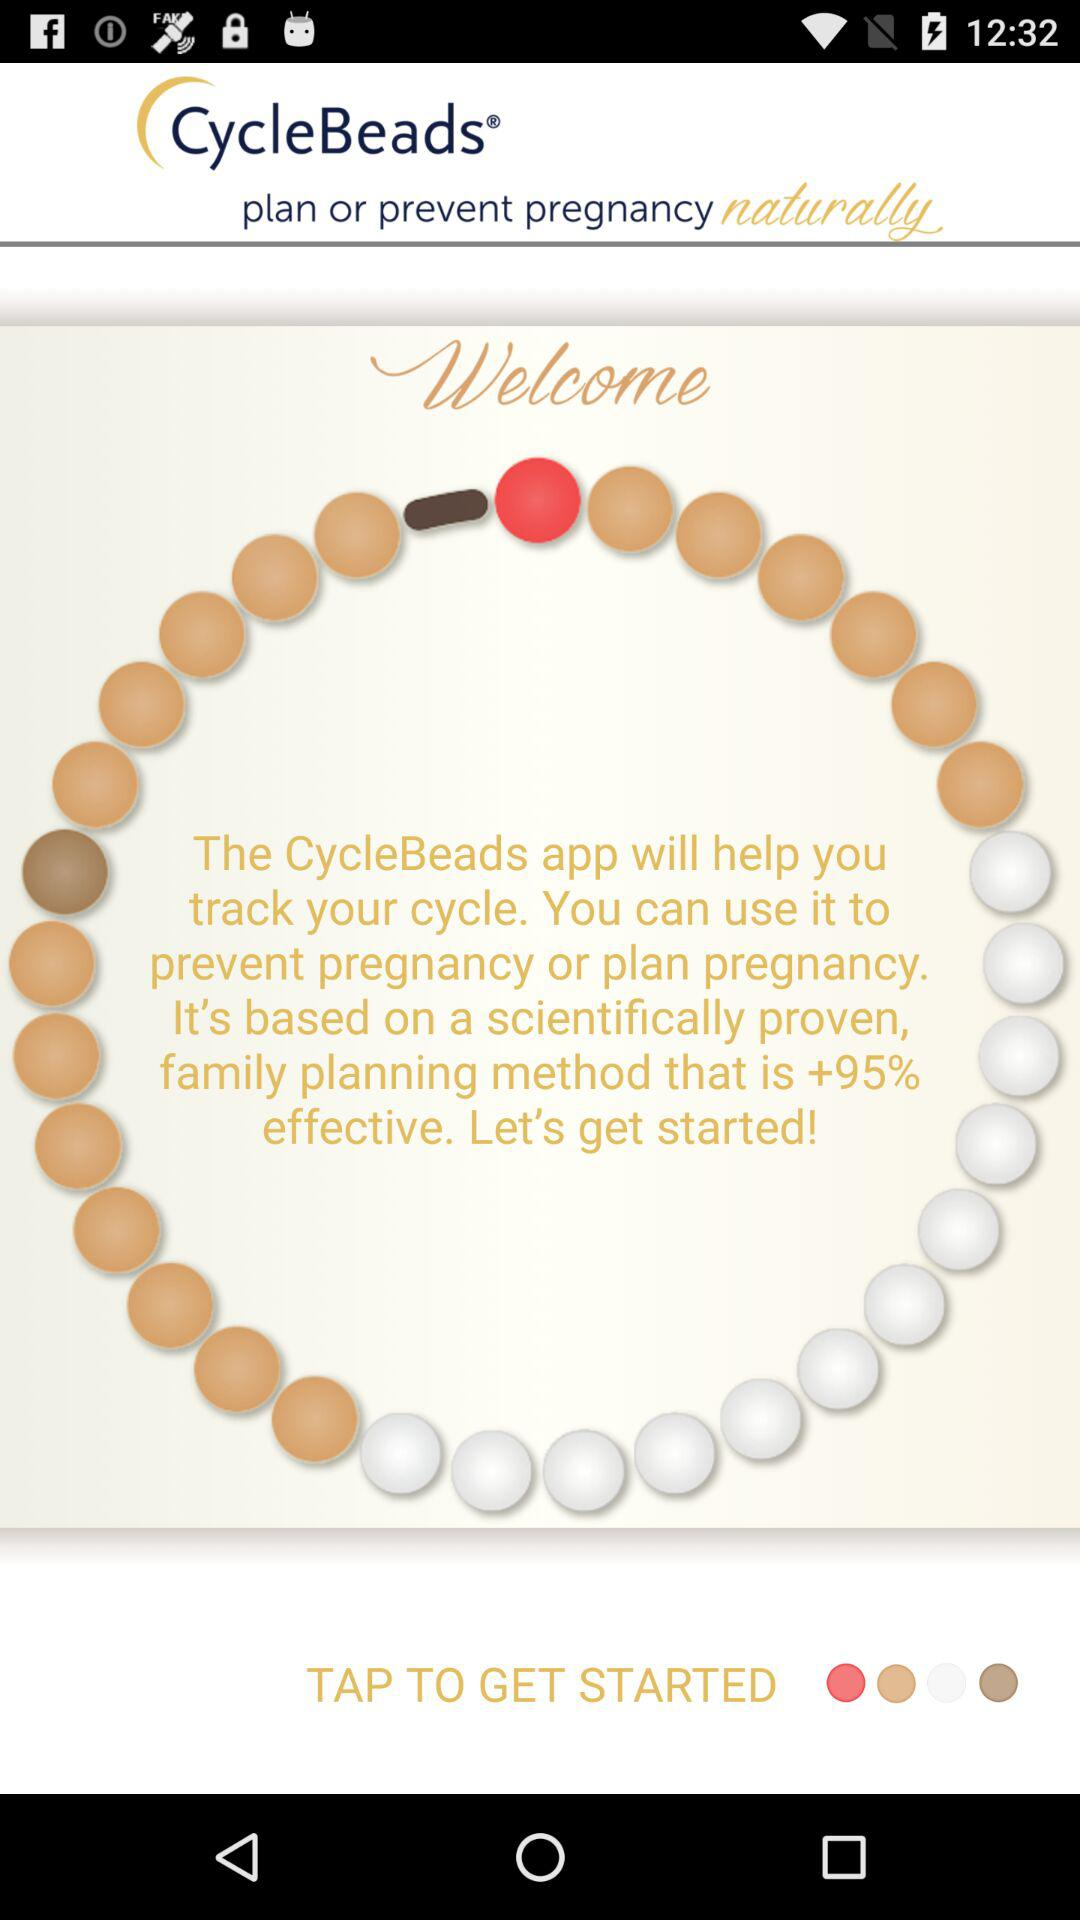How effective is this application? The CycleBeads app will help you track your cycle. You can use it to prevent pregnancy or plan pregnancy. It's based on a scientifically proven family planning method that is +95% effective. 